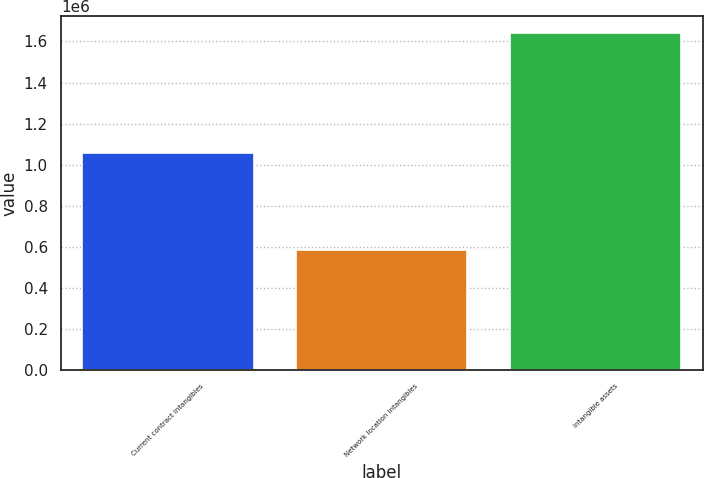<chart> <loc_0><loc_0><loc_500><loc_500><bar_chart><fcel>Current contract intangibles<fcel>Network location intangibles<fcel>Intangible assets<nl><fcel>1.05748e+06<fcel>582305<fcel>1.63978e+06<nl></chart> 